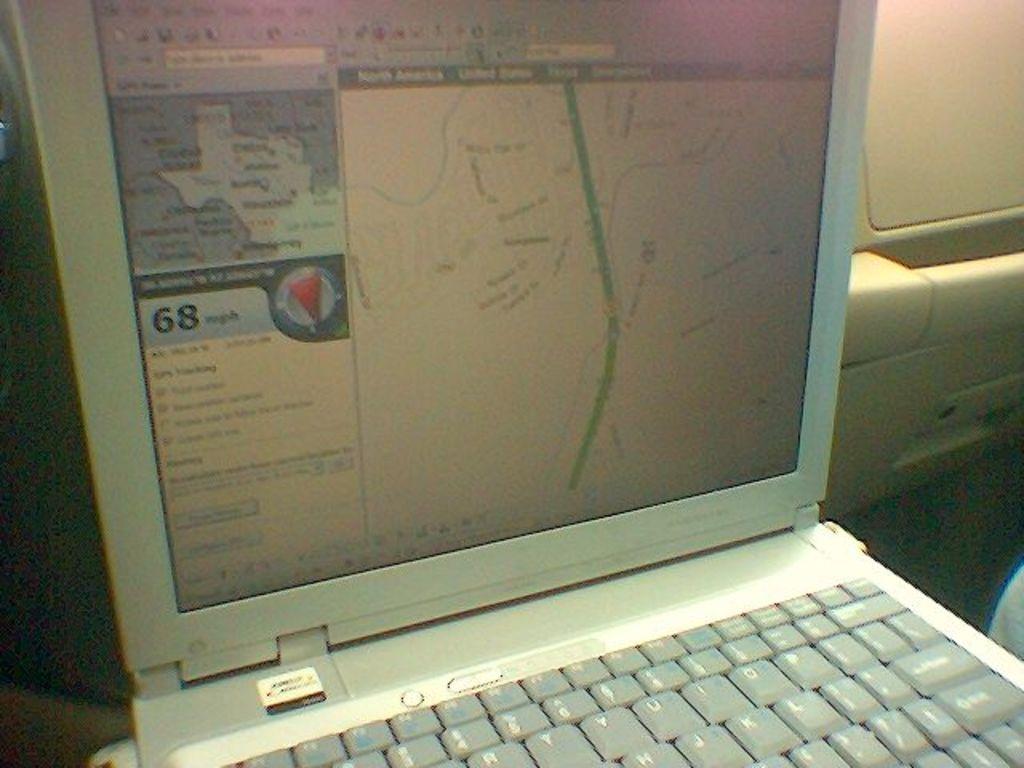How many mph?
Keep it short and to the point. 68. 